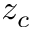<formula> <loc_0><loc_0><loc_500><loc_500>z _ { c }</formula> 